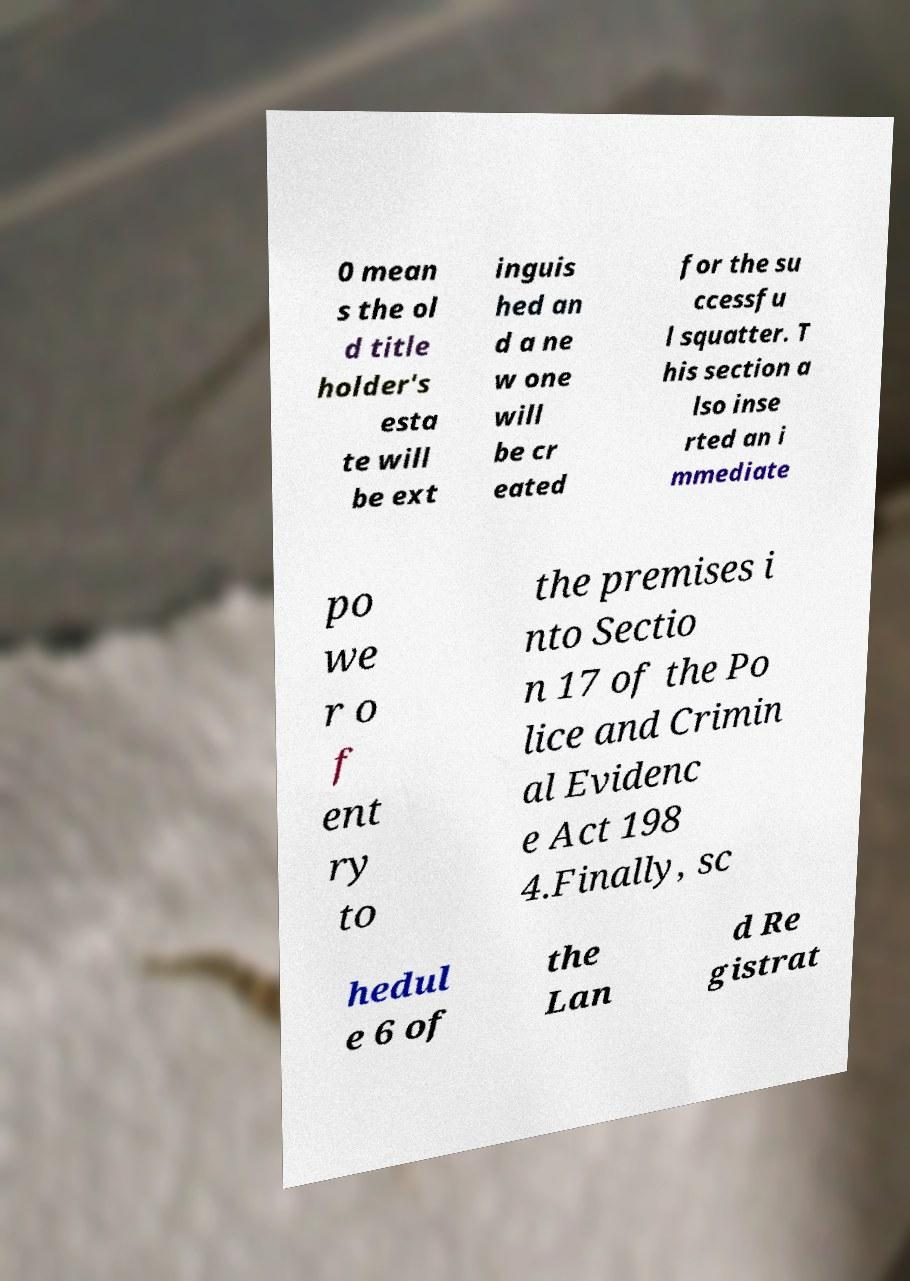Please identify and transcribe the text found in this image. 0 mean s the ol d title holder's esta te will be ext inguis hed an d a ne w one will be cr eated for the su ccessfu l squatter. T his section a lso inse rted an i mmediate po we r o f ent ry to the premises i nto Sectio n 17 of the Po lice and Crimin al Evidenc e Act 198 4.Finally, sc hedul e 6 of the Lan d Re gistrat 